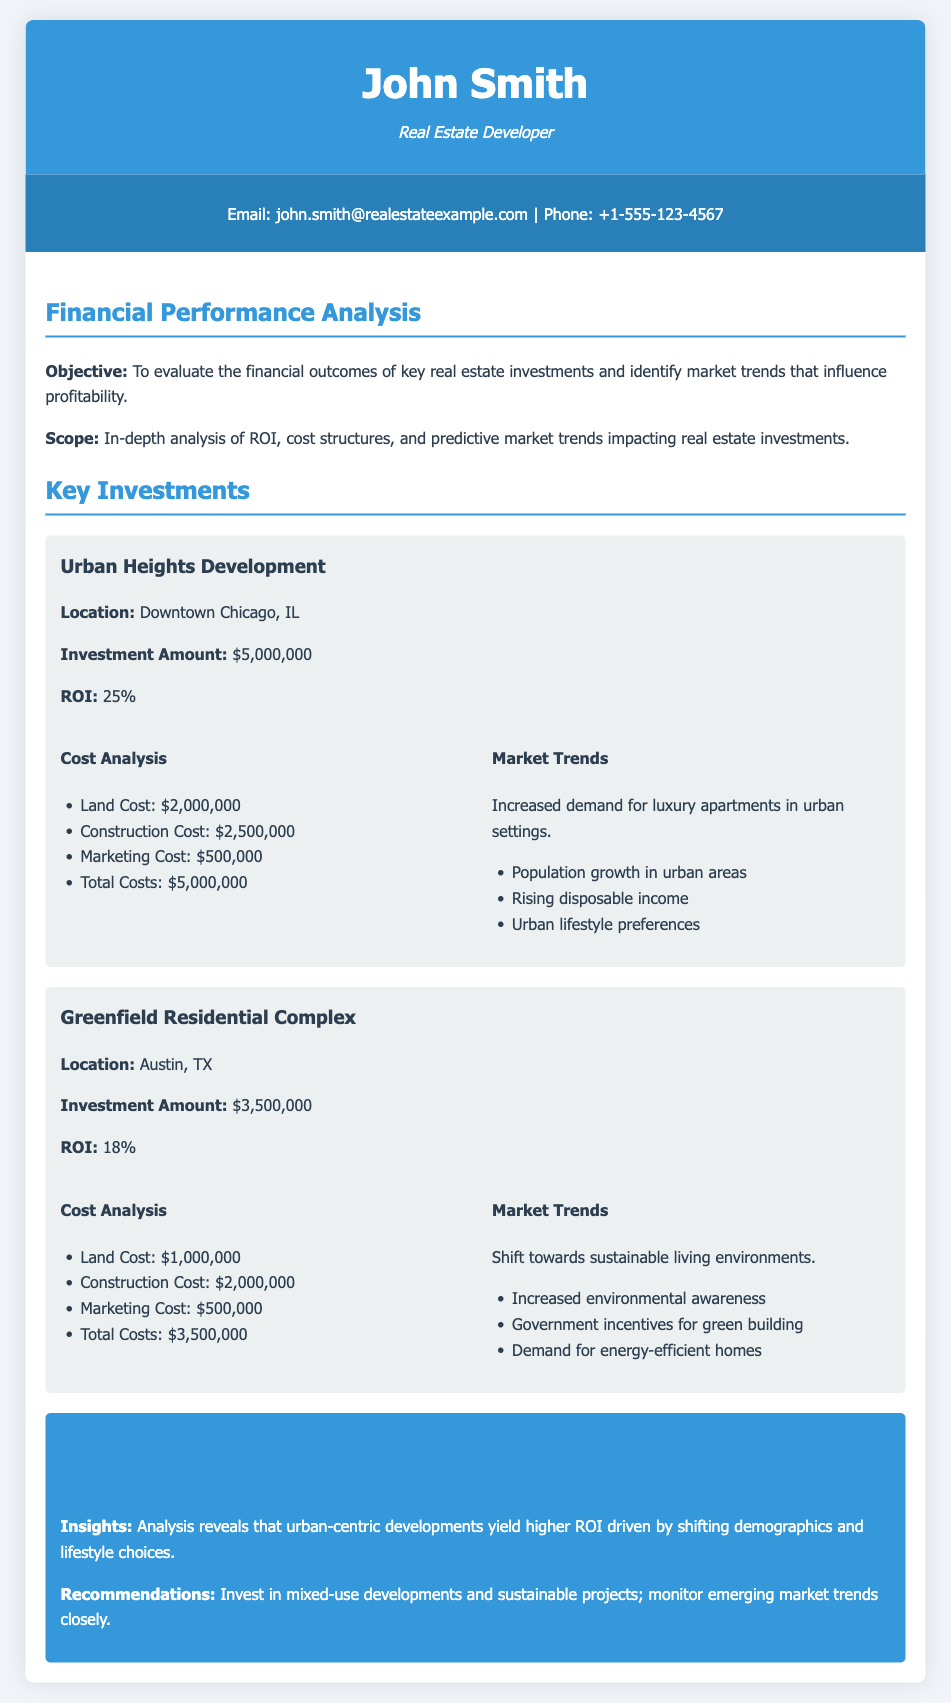what is the investment amount for Urban Heights Development? The investment amount for Urban Heights Development is specified in the document.
Answer: $5,000,000 what is the ROI for the Greenfield Residential Complex? The ROI for the Greenfield Residential Complex is detailed in the project section.
Answer: 18% what are the total costs for Urban Heights Development? The total costs for Urban Heights Development are provided in the cost analysis.
Answer: $5,000,000 what market trend is associated with Urban Heights Development? The market trend influencing Urban Heights Development is mentioned in the project details.
Answer: Increased demand for luxury apartments in urban settings what recommendation is given in the conclusion? The document provides recommendations based on the analysis of investments.
Answer: Invest in mixed-use developments and sustainable projects what is the location of the Greenfield Residential Complex? The location of the Greenfield Residential Complex is mentioned in the project details.
Answer: Austin, TX what is the land cost for Greenfield Residential Complex? The land cost for Greenfield Residential Complex is indicated in the cost analysis.
Answer: $1,000,000 what is the marketing cost for Urban Heights Development? The marketing cost for Urban Heights Development is detailed in the cost analysis.
Answer: $500,000 